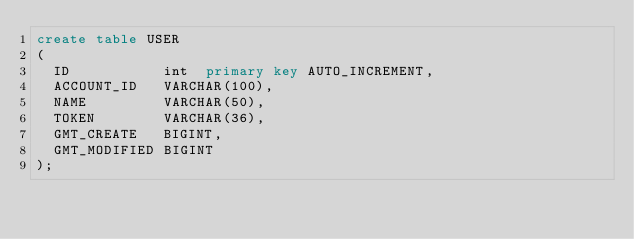<code> <loc_0><loc_0><loc_500><loc_500><_SQL_>create table USER
(
  ID           int  primary key AUTO_INCREMENT,
  ACCOUNT_ID   VARCHAR(100),
  NAME         VARCHAR(50),
  TOKEN        VARCHAR(36),
  GMT_CREATE   BIGINT,
  GMT_MODIFIED BIGINT
);
</code> 